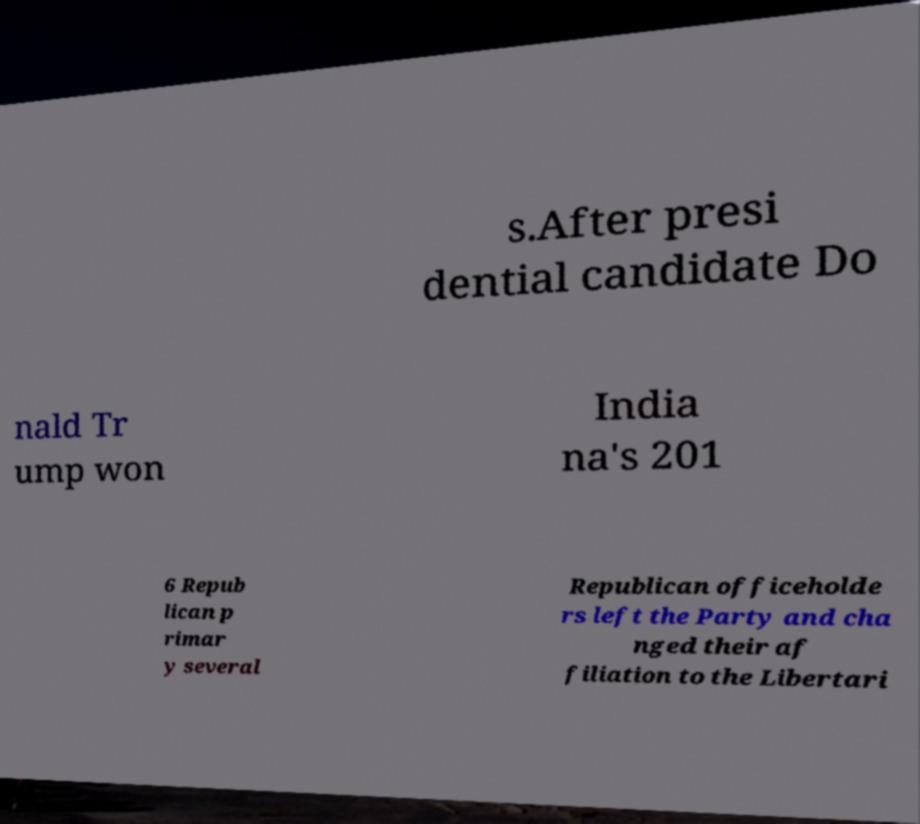Can you read and provide the text displayed in the image?This photo seems to have some interesting text. Can you extract and type it out for me? s.After presi dential candidate Do nald Tr ump won India na's 201 6 Repub lican p rimar y several Republican officeholde rs left the Party and cha nged their af filiation to the Libertari 